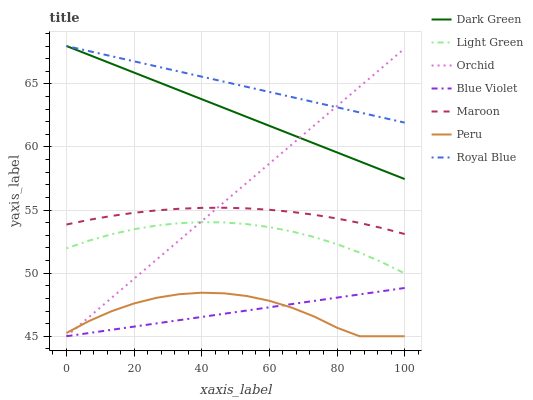Does Blue Violet have the minimum area under the curve?
Answer yes or no. Yes. Does Royal Blue have the maximum area under the curve?
Answer yes or no. Yes. Does Maroon have the minimum area under the curve?
Answer yes or no. No. Does Maroon have the maximum area under the curve?
Answer yes or no. No. Is Blue Violet the smoothest?
Answer yes or no. Yes. Is Peru the roughest?
Answer yes or no. Yes. Is Maroon the smoothest?
Answer yes or no. No. Is Maroon the roughest?
Answer yes or no. No. Does Peru have the lowest value?
Answer yes or no. Yes. Does Maroon have the lowest value?
Answer yes or no. No. Does Dark Green have the highest value?
Answer yes or no. Yes. Does Maroon have the highest value?
Answer yes or no. No. Is Blue Violet less than Dark Green?
Answer yes or no. Yes. Is Dark Green greater than Maroon?
Answer yes or no. Yes. Does Dark Green intersect Orchid?
Answer yes or no. Yes. Is Dark Green less than Orchid?
Answer yes or no. No. Is Dark Green greater than Orchid?
Answer yes or no. No. Does Blue Violet intersect Dark Green?
Answer yes or no. No. 